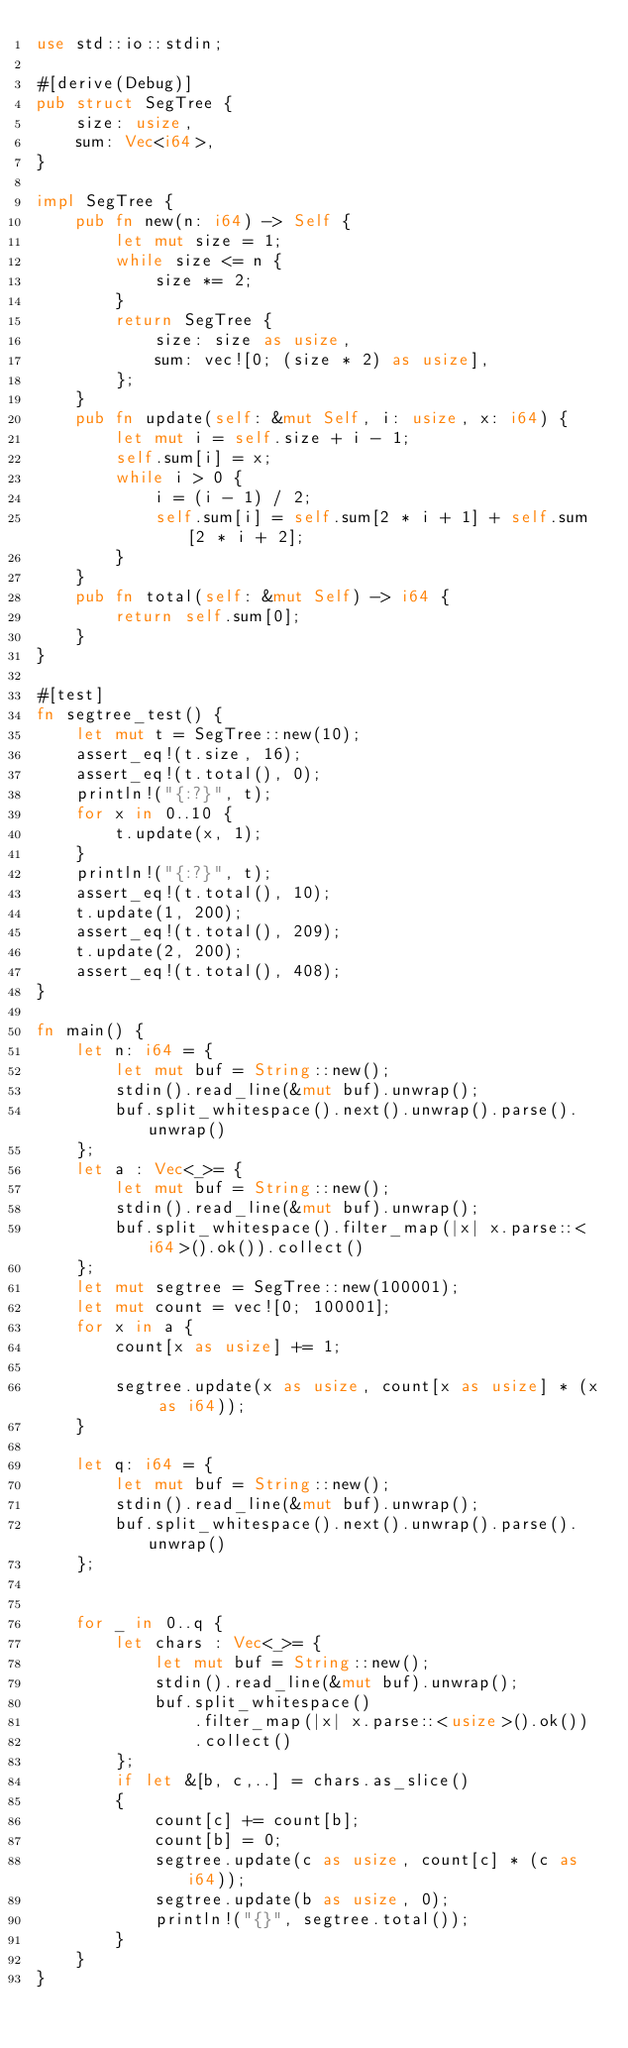Convert code to text. <code><loc_0><loc_0><loc_500><loc_500><_Rust_>use std::io::stdin;

#[derive(Debug)]
pub struct SegTree {
    size: usize,
    sum: Vec<i64>,
}

impl SegTree {
    pub fn new(n: i64) -> Self {
        let mut size = 1;
        while size <= n {
            size *= 2;
        }
        return SegTree {
            size: size as usize,
            sum: vec![0; (size * 2) as usize],
        };
    }
    pub fn update(self: &mut Self, i: usize, x: i64) {
        let mut i = self.size + i - 1;
        self.sum[i] = x;
        while i > 0 {
            i = (i - 1) / 2;
            self.sum[i] = self.sum[2 * i + 1] + self.sum[2 * i + 2];
        }
    }
    pub fn total(self: &mut Self) -> i64 {
        return self.sum[0];
    }
}

#[test]
fn segtree_test() {
    let mut t = SegTree::new(10);
    assert_eq!(t.size, 16);
    assert_eq!(t.total(), 0);
    println!("{:?}", t);
    for x in 0..10 {
        t.update(x, 1);
    }
    println!("{:?}", t);
    assert_eq!(t.total(), 10);
    t.update(1, 200);
    assert_eq!(t.total(), 209);
    t.update(2, 200);
    assert_eq!(t.total(), 408);
}

fn main() {
    let n: i64 = {
        let mut buf = String::new();
        stdin().read_line(&mut buf).unwrap();
        buf.split_whitespace().next().unwrap().parse().unwrap()
    };
    let a : Vec<_>= {
        let mut buf = String::new();
        stdin().read_line(&mut buf).unwrap();
        buf.split_whitespace().filter_map(|x| x.parse::<i64>().ok()).collect()
    };
    let mut segtree = SegTree::new(100001);
    let mut count = vec![0; 100001];
    for x in a {
        count[x as usize] += 1;

        segtree.update(x as usize, count[x as usize] * (x as i64));
    }

    let q: i64 = {
        let mut buf = String::new();
        stdin().read_line(&mut buf).unwrap();
        buf.split_whitespace().next().unwrap().parse().unwrap()
    };


    for _ in 0..q {
        let chars : Vec<_>= {
            let mut buf = String::new();
            stdin().read_line(&mut buf).unwrap();
            buf.split_whitespace()
                .filter_map(|x| x.parse::<usize>().ok())
                .collect()
        };
        if let &[b, c,..] = chars.as_slice()
        {
            count[c] += count[b];
            count[b] = 0;
            segtree.update(c as usize, count[c] * (c as i64));
            segtree.update(b as usize, 0);
            println!("{}", segtree.total());
        }
    }
}
</code> 